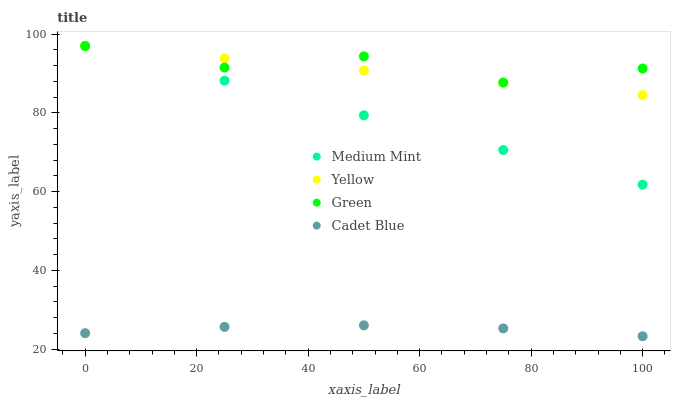Does Cadet Blue have the minimum area under the curve?
Answer yes or no. Yes. Does Green have the maximum area under the curve?
Answer yes or no. Yes. Does Green have the minimum area under the curve?
Answer yes or no. No. Does Cadet Blue have the maximum area under the curve?
Answer yes or no. No. Is Medium Mint the smoothest?
Answer yes or no. Yes. Is Green the roughest?
Answer yes or no. Yes. Is Cadet Blue the smoothest?
Answer yes or no. No. Is Cadet Blue the roughest?
Answer yes or no. No. Does Cadet Blue have the lowest value?
Answer yes or no. Yes. Does Green have the lowest value?
Answer yes or no. No. Does Yellow have the highest value?
Answer yes or no. Yes. Does Cadet Blue have the highest value?
Answer yes or no. No. Is Cadet Blue less than Yellow?
Answer yes or no. Yes. Is Medium Mint greater than Cadet Blue?
Answer yes or no. Yes. Does Green intersect Medium Mint?
Answer yes or no. Yes. Is Green less than Medium Mint?
Answer yes or no. No. Is Green greater than Medium Mint?
Answer yes or no. No. Does Cadet Blue intersect Yellow?
Answer yes or no. No. 